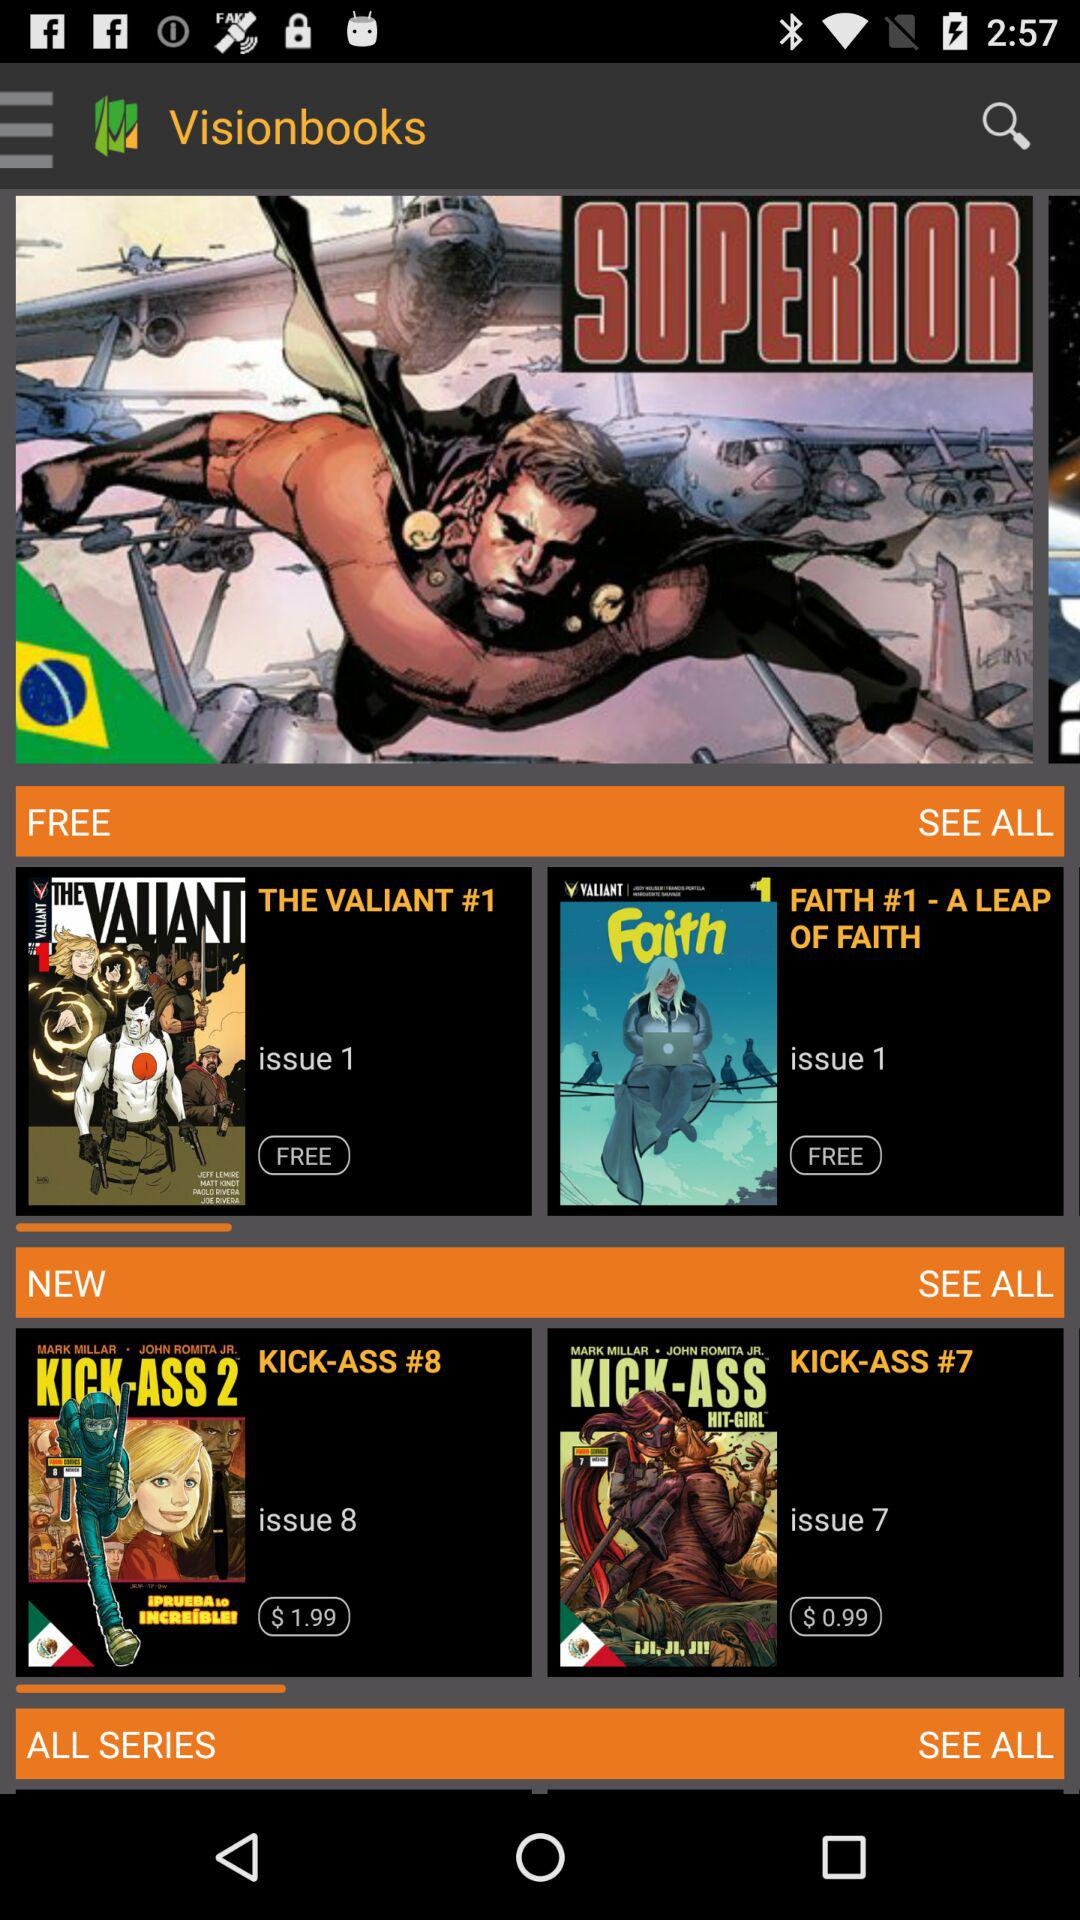Which books have the free version? The books having free versions are "THE VALIANT #1" and "FAITH #1 - A LEAP OF FAITH". 